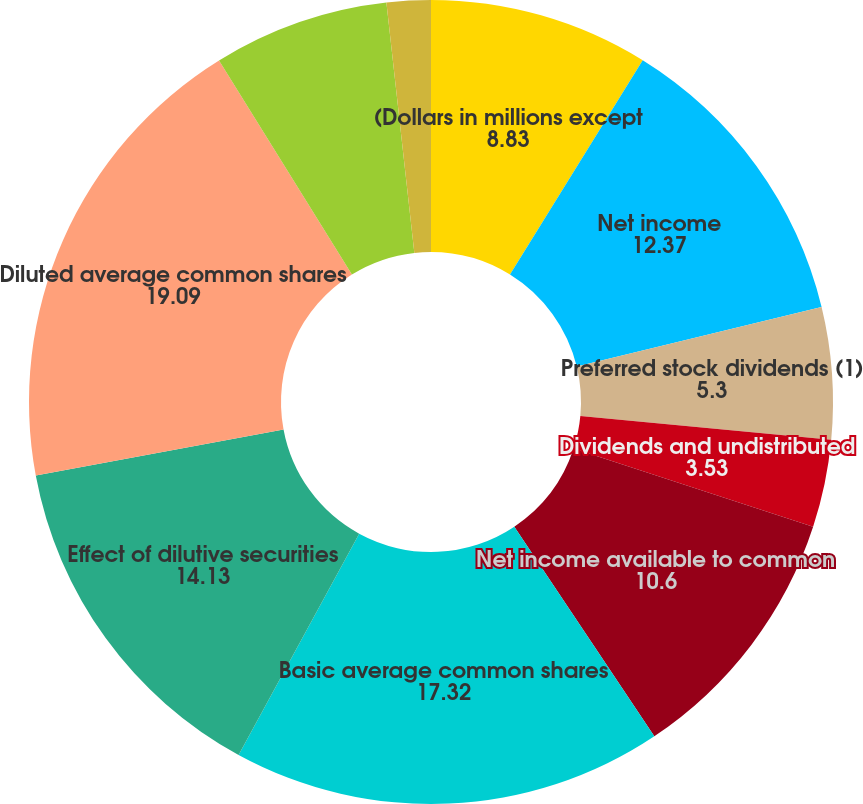<chart> <loc_0><loc_0><loc_500><loc_500><pie_chart><fcel>(Dollars in millions except<fcel>Net income<fcel>Preferred stock dividends (1)<fcel>Dividends and undistributed<fcel>Net income available to common<fcel>Basic average common shares<fcel>Effect of dilutive securities<fcel>Diluted average common shares<fcel>Anti-dilutive securities (3)<fcel>Basic<nl><fcel>8.83%<fcel>12.37%<fcel>5.3%<fcel>3.53%<fcel>10.6%<fcel>17.32%<fcel>14.13%<fcel>19.09%<fcel>7.07%<fcel>1.77%<nl></chart> 